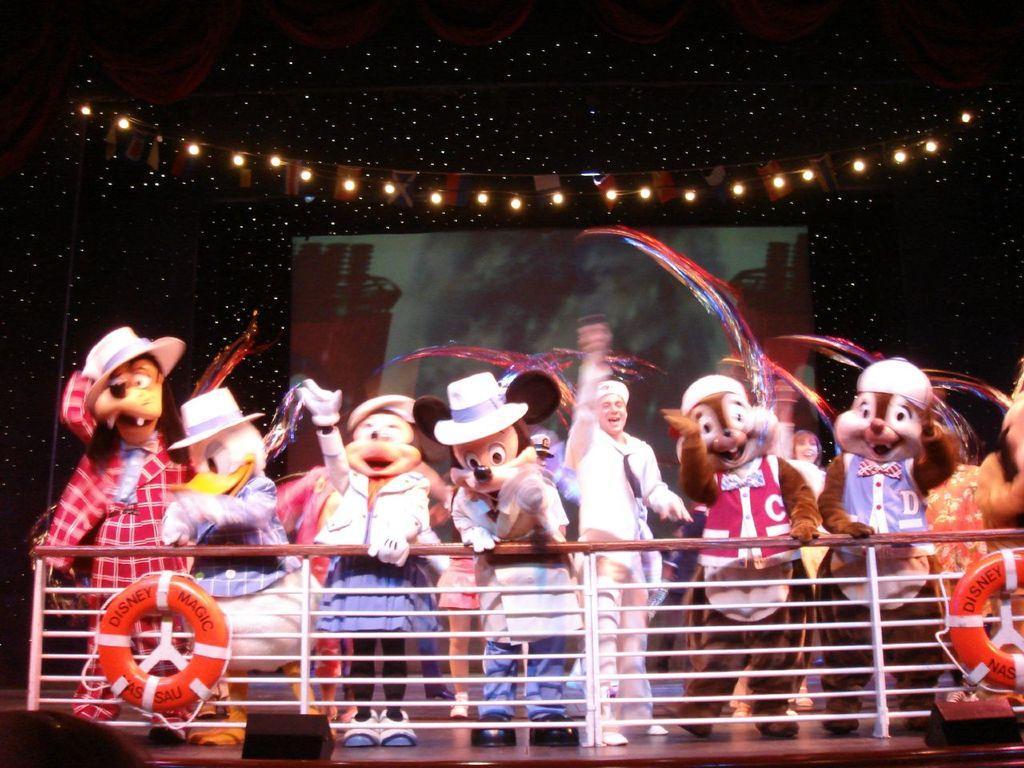How would you summarize this image in a sentence or two? In this image, we can see few people wore different costumes and standing on the floor. Here we can see railing, tubes. Background there is a screen, lights, banner. 